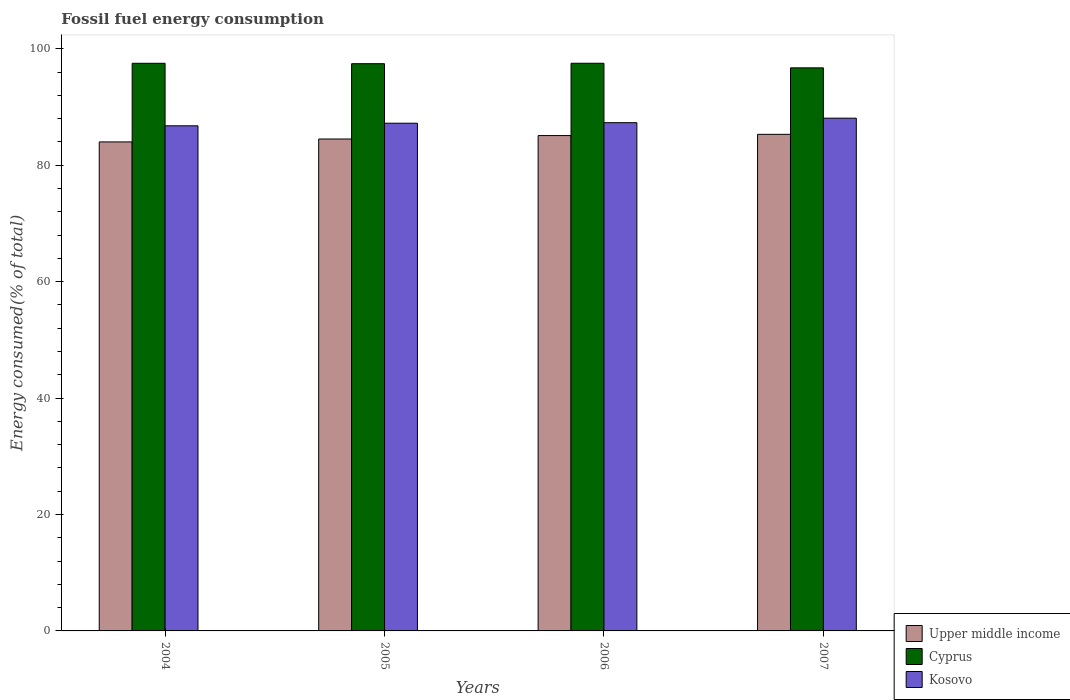How many different coloured bars are there?
Keep it short and to the point. 3. How many bars are there on the 1st tick from the right?
Offer a very short reply. 3. What is the percentage of energy consumed in Kosovo in 2005?
Keep it short and to the point. 87.21. Across all years, what is the maximum percentage of energy consumed in Upper middle income?
Your answer should be very brief. 85.3. Across all years, what is the minimum percentage of energy consumed in Cyprus?
Keep it short and to the point. 96.72. What is the total percentage of energy consumed in Cyprus in the graph?
Give a very brief answer. 389.15. What is the difference between the percentage of energy consumed in Upper middle income in 2006 and that in 2007?
Offer a terse response. -0.21. What is the difference between the percentage of energy consumed in Upper middle income in 2005 and the percentage of energy consumed in Cyprus in 2006?
Your answer should be very brief. -13.01. What is the average percentage of energy consumed in Upper middle income per year?
Your response must be concise. 84.72. In the year 2007, what is the difference between the percentage of energy consumed in Kosovo and percentage of energy consumed in Cyprus?
Provide a short and direct response. -8.64. In how many years, is the percentage of energy consumed in Upper middle income greater than 8 %?
Offer a very short reply. 4. What is the ratio of the percentage of energy consumed in Cyprus in 2005 to that in 2007?
Your answer should be compact. 1.01. Is the difference between the percentage of energy consumed in Kosovo in 2005 and 2007 greater than the difference between the percentage of energy consumed in Cyprus in 2005 and 2007?
Offer a very short reply. No. What is the difference between the highest and the second highest percentage of energy consumed in Kosovo?
Provide a short and direct response. 0.77. What is the difference between the highest and the lowest percentage of energy consumed in Upper middle income?
Offer a terse response. 1.3. In how many years, is the percentage of energy consumed in Cyprus greater than the average percentage of energy consumed in Cyprus taken over all years?
Keep it short and to the point. 3. What does the 3rd bar from the left in 2005 represents?
Keep it short and to the point. Kosovo. What does the 2nd bar from the right in 2006 represents?
Your response must be concise. Cyprus. Is it the case that in every year, the sum of the percentage of energy consumed in Upper middle income and percentage of energy consumed in Kosovo is greater than the percentage of energy consumed in Cyprus?
Provide a succinct answer. Yes. How many bars are there?
Your answer should be very brief. 12. Are all the bars in the graph horizontal?
Your answer should be compact. No. How many years are there in the graph?
Ensure brevity in your answer.  4. What is the difference between two consecutive major ticks on the Y-axis?
Your answer should be compact. 20. Are the values on the major ticks of Y-axis written in scientific E-notation?
Your answer should be very brief. No. Does the graph contain any zero values?
Your answer should be very brief. No. How many legend labels are there?
Your answer should be compact. 3. What is the title of the graph?
Keep it short and to the point. Fossil fuel energy consumption. What is the label or title of the X-axis?
Your answer should be very brief. Years. What is the label or title of the Y-axis?
Offer a very short reply. Energy consumed(% of total). What is the Energy consumed(% of total) in Upper middle income in 2004?
Provide a succinct answer. 83.99. What is the Energy consumed(% of total) in Cyprus in 2004?
Keep it short and to the point. 97.5. What is the Energy consumed(% of total) of Kosovo in 2004?
Ensure brevity in your answer.  86.76. What is the Energy consumed(% of total) of Upper middle income in 2005?
Keep it short and to the point. 84.5. What is the Energy consumed(% of total) of Cyprus in 2005?
Keep it short and to the point. 97.43. What is the Energy consumed(% of total) in Kosovo in 2005?
Keep it short and to the point. 87.21. What is the Energy consumed(% of total) in Upper middle income in 2006?
Your answer should be very brief. 85.08. What is the Energy consumed(% of total) of Cyprus in 2006?
Ensure brevity in your answer.  97.51. What is the Energy consumed(% of total) of Kosovo in 2006?
Give a very brief answer. 87.3. What is the Energy consumed(% of total) of Upper middle income in 2007?
Your answer should be very brief. 85.3. What is the Energy consumed(% of total) in Cyprus in 2007?
Give a very brief answer. 96.72. What is the Energy consumed(% of total) in Kosovo in 2007?
Offer a terse response. 88.07. Across all years, what is the maximum Energy consumed(% of total) of Upper middle income?
Give a very brief answer. 85.3. Across all years, what is the maximum Energy consumed(% of total) of Cyprus?
Offer a very short reply. 97.51. Across all years, what is the maximum Energy consumed(% of total) of Kosovo?
Your response must be concise. 88.07. Across all years, what is the minimum Energy consumed(% of total) of Upper middle income?
Your answer should be compact. 83.99. Across all years, what is the minimum Energy consumed(% of total) of Cyprus?
Your answer should be very brief. 96.72. Across all years, what is the minimum Energy consumed(% of total) of Kosovo?
Your response must be concise. 86.76. What is the total Energy consumed(% of total) in Upper middle income in the graph?
Provide a succinct answer. 338.87. What is the total Energy consumed(% of total) of Cyprus in the graph?
Offer a terse response. 389.15. What is the total Energy consumed(% of total) in Kosovo in the graph?
Ensure brevity in your answer.  349.34. What is the difference between the Energy consumed(% of total) in Upper middle income in 2004 and that in 2005?
Provide a short and direct response. -0.5. What is the difference between the Energy consumed(% of total) in Cyprus in 2004 and that in 2005?
Give a very brief answer. 0.07. What is the difference between the Energy consumed(% of total) in Kosovo in 2004 and that in 2005?
Give a very brief answer. -0.45. What is the difference between the Energy consumed(% of total) of Upper middle income in 2004 and that in 2006?
Provide a short and direct response. -1.09. What is the difference between the Energy consumed(% of total) of Cyprus in 2004 and that in 2006?
Offer a very short reply. -0.01. What is the difference between the Energy consumed(% of total) in Kosovo in 2004 and that in 2006?
Offer a very short reply. -0.54. What is the difference between the Energy consumed(% of total) of Upper middle income in 2004 and that in 2007?
Provide a short and direct response. -1.3. What is the difference between the Energy consumed(% of total) of Cyprus in 2004 and that in 2007?
Ensure brevity in your answer.  0.78. What is the difference between the Energy consumed(% of total) in Kosovo in 2004 and that in 2007?
Provide a succinct answer. -1.31. What is the difference between the Energy consumed(% of total) of Upper middle income in 2005 and that in 2006?
Give a very brief answer. -0.59. What is the difference between the Energy consumed(% of total) in Cyprus in 2005 and that in 2006?
Give a very brief answer. -0.07. What is the difference between the Energy consumed(% of total) in Kosovo in 2005 and that in 2006?
Offer a very short reply. -0.09. What is the difference between the Energy consumed(% of total) in Upper middle income in 2005 and that in 2007?
Offer a terse response. -0.8. What is the difference between the Energy consumed(% of total) in Cyprus in 2005 and that in 2007?
Provide a succinct answer. 0.71. What is the difference between the Energy consumed(% of total) of Kosovo in 2005 and that in 2007?
Offer a very short reply. -0.87. What is the difference between the Energy consumed(% of total) in Upper middle income in 2006 and that in 2007?
Give a very brief answer. -0.21. What is the difference between the Energy consumed(% of total) in Cyprus in 2006 and that in 2007?
Give a very brief answer. 0.79. What is the difference between the Energy consumed(% of total) in Kosovo in 2006 and that in 2007?
Make the answer very short. -0.77. What is the difference between the Energy consumed(% of total) of Upper middle income in 2004 and the Energy consumed(% of total) of Cyprus in 2005?
Your response must be concise. -13.44. What is the difference between the Energy consumed(% of total) of Upper middle income in 2004 and the Energy consumed(% of total) of Kosovo in 2005?
Provide a short and direct response. -3.21. What is the difference between the Energy consumed(% of total) in Cyprus in 2004 and the Energy consumed(% of total) in Kosovo in 2005?
Ensure brevity in your answer.  10.29. What is the difference between the Energy consumed(% of total) of Upper middle income in 2004 and the Energy consumed(% of total) of Cyprus in 2006?
Make the answer very short. -13.51. What is the difference between the Energy consumed(% of total) in Upper middle income in 2004 and the Energy consumed(% of total) in Kosovo in 2006?
Your answer should be compact. -3.3. What is the difference between the Energy consumed(% of total) in Cyprus in 2004 and the Energy consumed(% of total) in Kosovo in 2006?
Make the answer very short. 10.2. What is the difference between the Energy consumed(% of total) in Upper middle income in 2004 and the Energy consumed(% of total) in Cyprus in 2007?
Provide a succinct answer. -12.72. What is the difference between the Energy consumed(% of total) in Upper middle income in 2004 and the Energy consumed(% of total) in Kosovo in 2007?
Offer a terse response. -4.08. What is the difference between the Energy consumed(% of total) in Cyprus in 2004 and the Energy consumed(% of total) in Kosovo in 2007?
Your answer should be compact. 9.43. What is the difference between the Energy consumed(% of total) of Upper middle income in 2005 and the Energy consumed(% of total) of Cyprus in 2006?
Your response must be concise. -13.01. What is the difference between the Energy consumed(% of total) of Upper middle income in 2005 and the Energy consumed(% of total) of Kosovo in 2006?
Ensure brevity in your answer.  -2.8. What is the difference between the Energy consumed(% of total) of Cyprus in 2005 and the Energy consumed(% of total) of Kosovo in 2006?
Your answer should be very brief. 10.13. What is the difference between the Energy consumed(% of total) of Upper middle income in 2005 and the Energy consumed(% of total) of Cyprus in 2007?
Provide a succinct answer. -12.22. What is the difference between the Energy consumed(% of total) in Upper middle income in 2005 and the Energy consumed(% of total) in Kosovo in 2007?
Ensure brevity in your answer.  -3.58. What is the difference between the Energy consumed(% of total) in Cyprus in 2005 and the Energy consumed(% of total) in Kosovo in 2007?
Make the answer very short. 9.36. What is the difference between the Energy consumed(% of total) of Upper middle income in 2006 and the Energy consumed(% of total) of Cyprus in 2007?
Keep it short and to the point. -11.63. What is the difference between the Energy consumed(% of total) of Upper middle income in 2006 and the Energy consumed(% of total) of Kosovo in 2007?
Offer a terse response. -2.99. What is the difference between the Energy consumed(% of total) in Cyprus in 2006 and the Energy consumed(% of total) in Kosovo in 2007?
Provide a succinct answer. 9.43. What is the average Energy consumed(% of total) in Upper middle income per year?
Your answer should be compact. 84.72. What is the average Energy consumed(% of total) of Cyprus per year?
Provide a succinct answer. 97.29. What is the average Energy consumed(% of total) of Kosovo per year?
Ensure brevity in your answer.  87.34. In the year 2004, what is the difference between the Energy consumed(% of total) in Upper middle income and Energy consumed(% of total) in Cyprus?
Your response must be concise. -13.51. In the year 2004, what is the difference between the Energy consumed(% of total) in Upper middle income and Energy consumed(% of total) in Kosovo?
Keep it short and to the point. -2.77. In the year 2004, what is the difference between the Energy consumed(% of total) in Cyprus and Energy consumed(% of total) in Kosovo?
Offer a terse response. 10.74. In the year 2005, what is the difference between the Energy consumed(% of total) in Upper middle income and Energy consumed(% of total) in Cyprus?
Provide a succinct answer. -12.93. In the year 2005, what is the difference between the Energy consumed(% of total) in Upper middle income and Energy consumed(% of total) in Kosovo?
Keep it short and to the point. -2.71. In the year 2005, what is the difference between the Energy consumed(% of total) in Cyprus and Energy consumed(% of total) in Kosovo?
Keep it short and to the point. 10.22. In the year 2006, what is the difference between the Energy consumed(% of total) in Upper middle income and Energy consumed(% of total) in Cyprus?
Your answer should be very brief. -12.42. In the year 2006, what is the difference between the Energy consumed(% of total) of Upper middle income and Energy consumed(% of total) of Kosovo?
Your answer should be compact. -2.21. In the year 2006, what is the difference between the Energy consumed(% of total) of Cyprus and Energy consumed(% of total) of Kosovo?
Provide a short and direct response. 10.21. In the year 2007, what is the difference between the Energy consumed(% of total) of Upper middle income and Energy consumed(% of total) of Cyprus?
Your response must be concise. -11.42. In the year 2007, what is the difference between the Energy consumed(% of total) in Upper middle income and Energy consumed(% of total) in Kosovo?
Make the answer very short. -2.78. In the year 2007, what is the difference between the Energy consumed(% of total) of Cyprus and Energy consumed(% of total) of Kosovo?
Your response must be concise. 8.64. What is the ratio of the Energy consumed(% of total) of Upper middle income in 2004 to that in 2005?
Your answer should be very brief. 0.99. What is the ratio of the Energy consumed(% of total) in Kosovo in 2004 to that in 2005?
Make the answer very short. 0.99. What is the ratio of the Energy consumed(% of total) of Upper middle income in 2004 to that in 2006?
Provide a short and direct response. 0.99. What is the ratio of the Energy consumed(% of total) in Cyprus in 2004 to that in 2006?
Offer a terse response. 1. What is the ratio of the Energy consumed(% of total) of Upper middle income in 2004 to that in 2007?
Your answer should be very brief. 0.98. What is the ratio of the Energy consumed(% of total) in Kosovo in 2004 to that in 2007?
Offer a very short reply. 0.99. What is the ratio of the Energy consumed(% of total) of Upper middle income in 2005 to that in 2006?
Ensure brevity in your answer.  0.99. What is the ratio of the Energy consumed(% of total) of Cyprus in 2005 to that in 2006?
Offer a very short reply. 1. What is the ratio of the Energy consumed(% of total) in Upper middle income in 2005 to that in 2007?
Give a very brief answer. 0.99. What is the ratio of the Energy consumed(% of total) of Cyprus in 2005 to that in 2007?
Provide a succinct answer. 1.01. What is the ratio of the Energy consumed(% of total) of Kosovo in 2005 to that in 2007?
Keep it short and to the point. 0.99. What is the ratio of the Energy consumed(% of total) of Upper middle income in 2006 to that in 2007?
Provide a short and direct response. 1. What is the ratio of the Energy consumed(% of total) of Cyprus in 2006 to that in 2007?
Provide a short and direct response. 1.01. What is the difference between the highest and the second highest Energy consumed(% of total) of Upper middle income?
Give a very brief answer. 0.21. What is the difference between the highest and the second highest Energy consumed(% of total) in Cyprus?
Ensure brevity in your answer.  0.01. What is the difference between the highest and the second highest Energy consumed(% of total) of Kosovo?
Your answer should be compact. 0.77. What is the difference between the highest and the lowest Energy consumed(% of total) of Upper middle income?
Offer a very short reply. 1.3. What is the difference between the highest and the lowest Energy consumed(% of total) in Cyprus?
Make the answer very short. 0.79. What is the difference between the highest and the lowest Energy consumed(% of total) of Kosovo?
Make the answer very short. 1.31. 